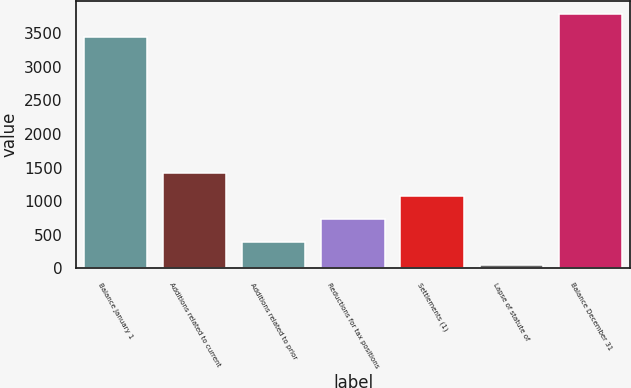<chart> <loc_0><loc_0><loc_500><loc_500><bar_chart><fcel>Balance January 1<fcel>Additions related to current<fcel>Additions related to prior<fcel>Reductions for tax positions<fcel>Settlements (1)<fcel>Lapse of statute of<fcel>Balance December 31<nl><fcel>3448<fcel>1423.4<fcel>388.1<fcel>733.2<fcel>1078.3<fcel>43<fcel>3793.1<nl></chart> 